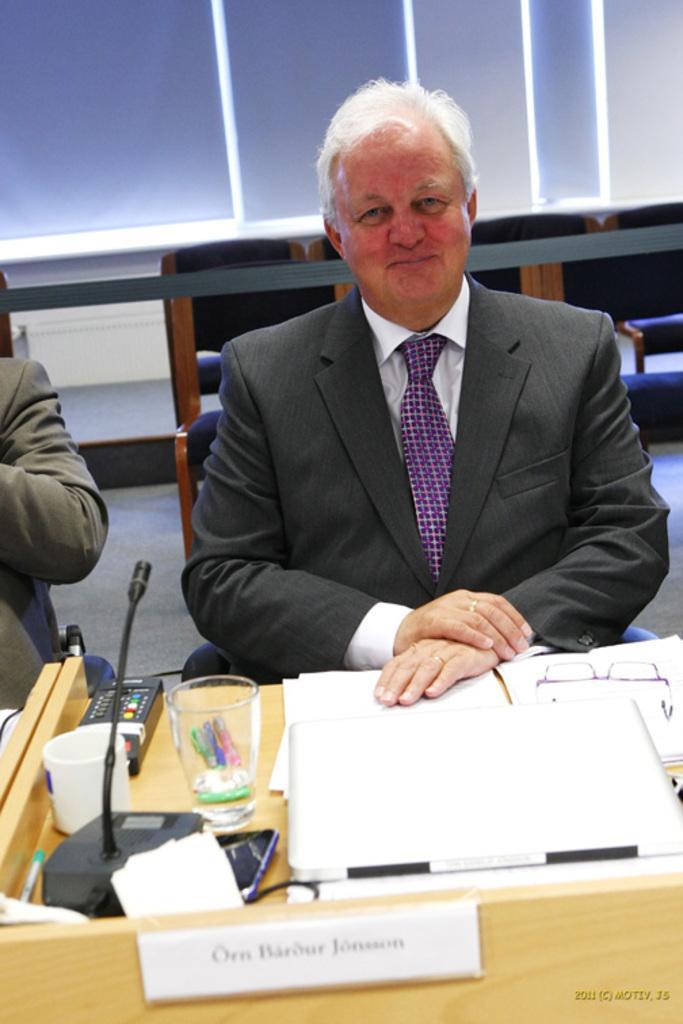In one or two sentences, can you explain what this image depicts? There is a man sitting on chair and smiling, beside him we can see another person. We can see papers, board, microphone and object on the table. In the background we can see wall and chairs. 